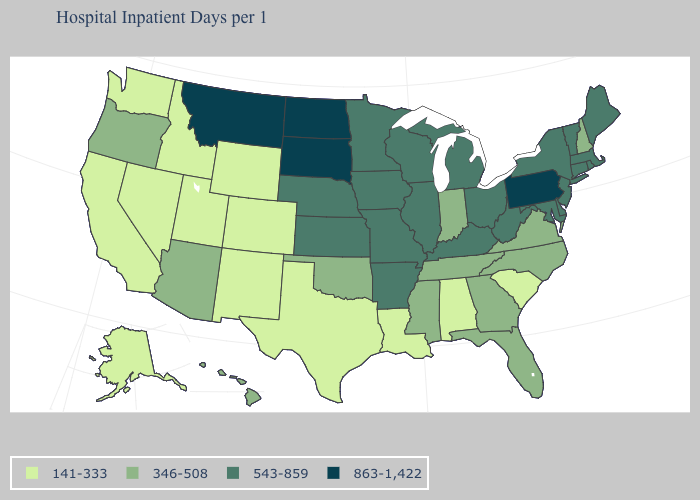Does Maryland have the highest value in the South?
Write a very short answer. Yes. Which states have the lowest value in the USA?
Short answer required. Alabama, Alaska, California, Colorado, Idaho, Louisiana, Nevada, New Mexico, South Carolina, Texas, Utah, Washington, Wyoming. Which states hav the highest value in the MidWest?
Concise answer only. North Dakota, South Dakota. What is the value of Washington?
Concise answer only. 141-333. Among the states that border Arkansas , which have the lowest value?
Short answer required. Louisiana, Texas. What is the lowest value in the USA?
Write a very short answer. 141-333. What is the value of Delaware?
Write a very short answer. 543-859. Does Indiana have the lowest value in the USA?
Short answer required. No. Name the states that have a value in the range 863-1,422?
Concise answer only. Montana, North Dakota, Pennsylvania, South Dakota. Among the states that border Georgia , which have the highest value?
Short answer required. Florida, North Carolina, Tennessee. Name the states that have a value in the range 543-859?
Short answer required. Arkansas, Connecticut, Delaware, Illinois, Iowa, Kansas, Kentucky, Maine, Maryland, Massachusetts, Michigan, Minnesota, Missouri, Nebraska, New Jersey, New York, Ohio, Rhode Island, Vermont, West Virginia, Wisconsin. What is the value of South Carolina?
Quick response, please. 141-333. Name the states that have a value in the range 141-333?
Concise answer only. Alabama, Alaska, California, Colorado, Idaho, Louisiana, Nevada, New Mexico, South Carolina, Texas, Utah, Washington, Wyoming. What is the lowest value in states that border Florida?
Short answer required. 141-333. What is the lowest value in states that border Louisiana?
Answer briefly. 141-333. 